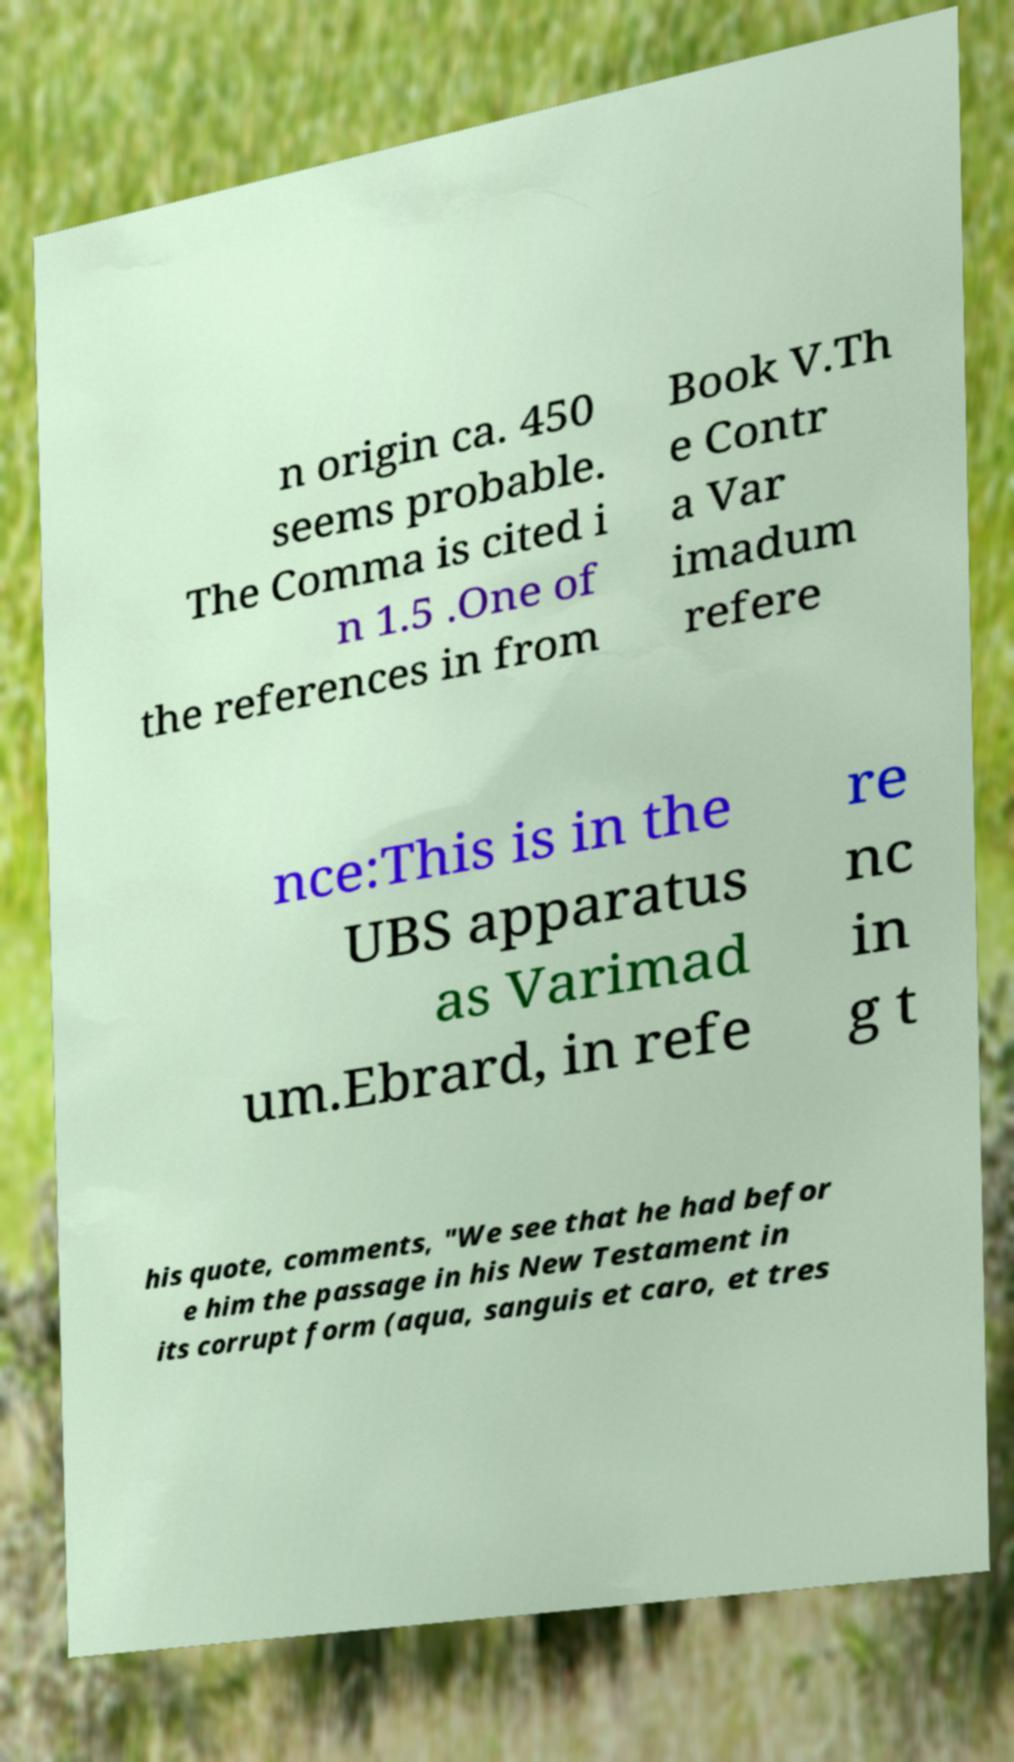There's text embedded in this image that I need extracted. Can you transcribe it verbatim? n origin ca. 450 seems probable. The Comma is cited i n 1.5 .One of the references in from Book V.Th e Contr a Var imadum refere nce:This is in the UBS apparatus as Varimad um.Ebrard, in refe re nc in g t his quote, comments, "We see that he had befor e him the passage in his New Testament in its corrupt form (aqua, sanguis et caro, et tres 